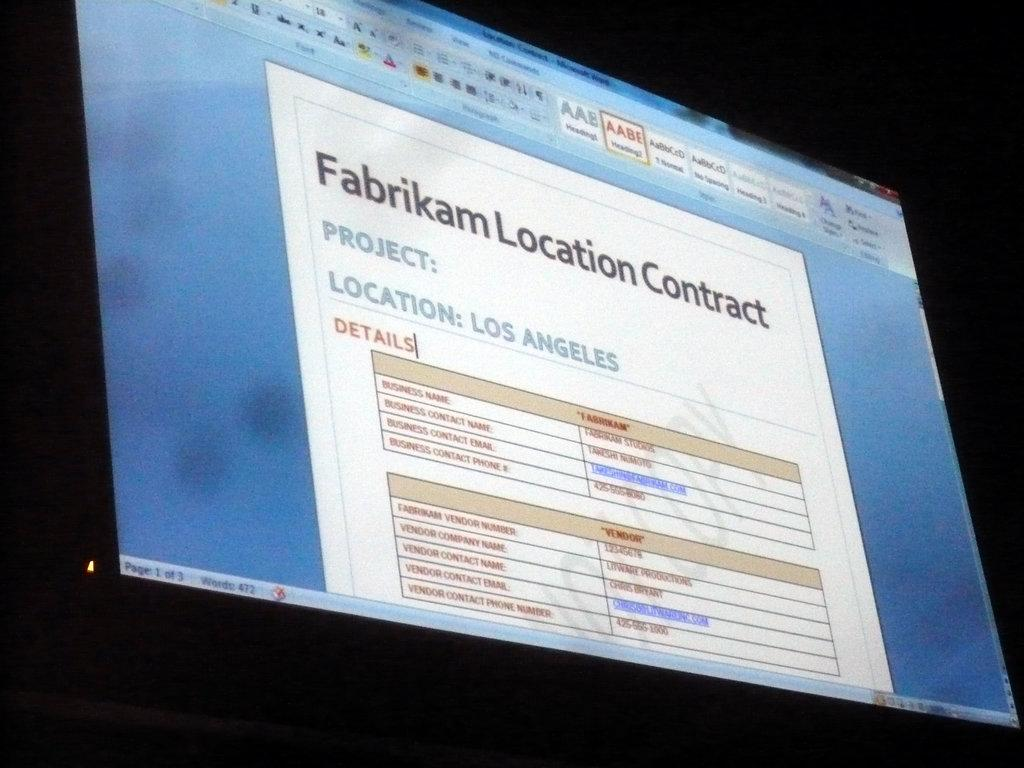<image>
Offer a succinct explanation of the picture presented. A computer screen shows a document titled "Fabrikam Location Contract." 